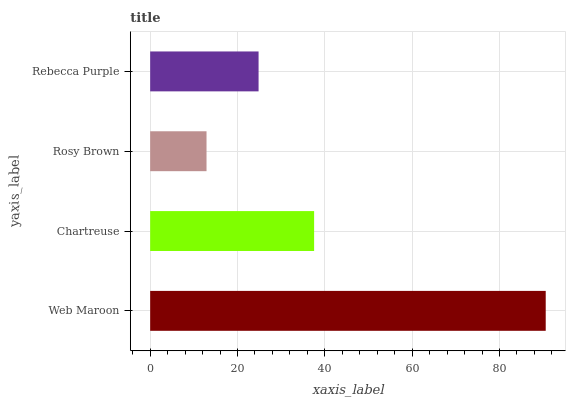Is Rosy Brown the minimum?
Answer yes or no. Yes. Is Web Maroon the maximum?
Answer yes or no. Yes. Is Chartreuse the minimum?
Answer yes or no. No. Is Chartreuse the maximum?
Answer yes or no. No. Is Web Maroon greater than Chartreuse?
Answer yes or no. Yes. Is Chartreuse less than Web Maroon?
Answer yes or no. Yes. Is Chartreuse greater than Web Maroon?
Answer yes or no. No. Is Web Maroon less than Chartreuse?
Answer yes or no. No. Is Chartreuse the high median?
Answer yes or no. Yes. Is Rebecca Purple the low median?
Answer yes or no. Yes. Is Rebecca Purple the high median?
Answer yes or no. No. Is Chartreuse the low median?
Answer yes or no. No. 